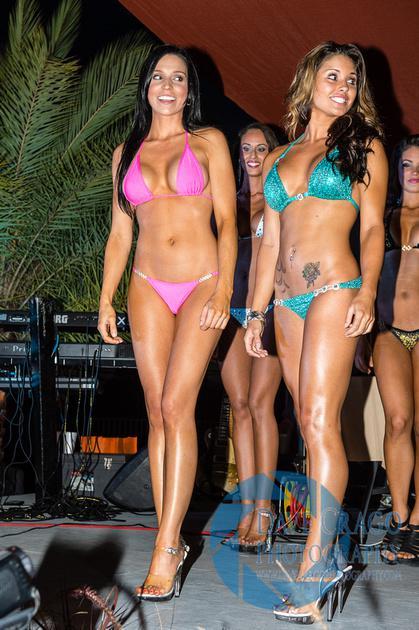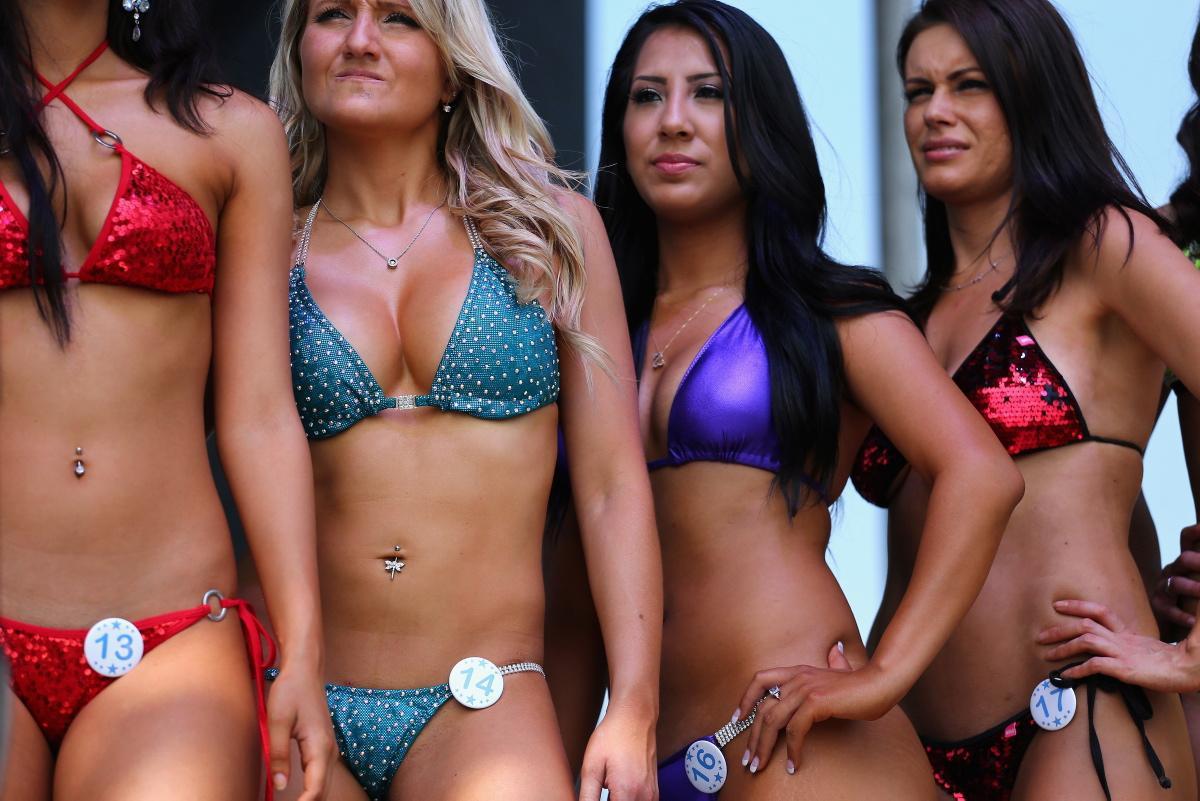The first image is the image on the left, the second image is the image on the right. Examine the images to the left and right. Is the description "An image shows exactly three bikini models posed side-by-side, and at least one wears an orange bikini bottom." accurate? Answer yes or no. No. 